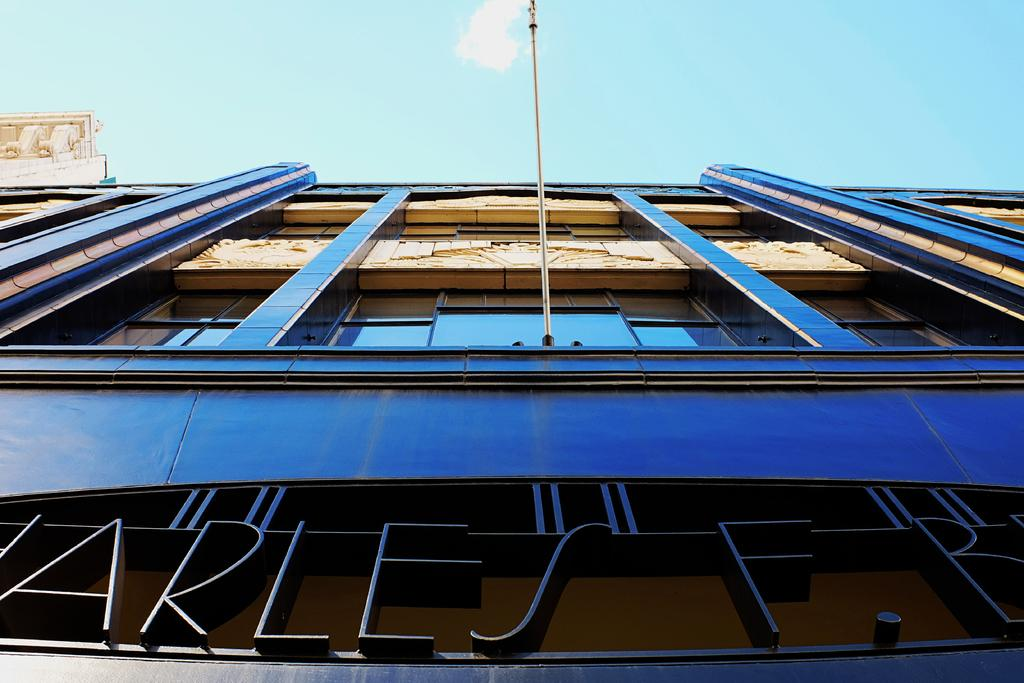What type of structure is visible in the image? There is a building with windows in the image. Can you describe any other objects in the image? There is a pole in the image. What can be seen in the background of the image? The sky is visible in the image. Is there any text present in the image? Yes, there is some text written at the bottom of the image. What type of shoes can be seen being destroyed in the image? There are no shoes present in the image, and therefore no destruction of shoes can be observed. 